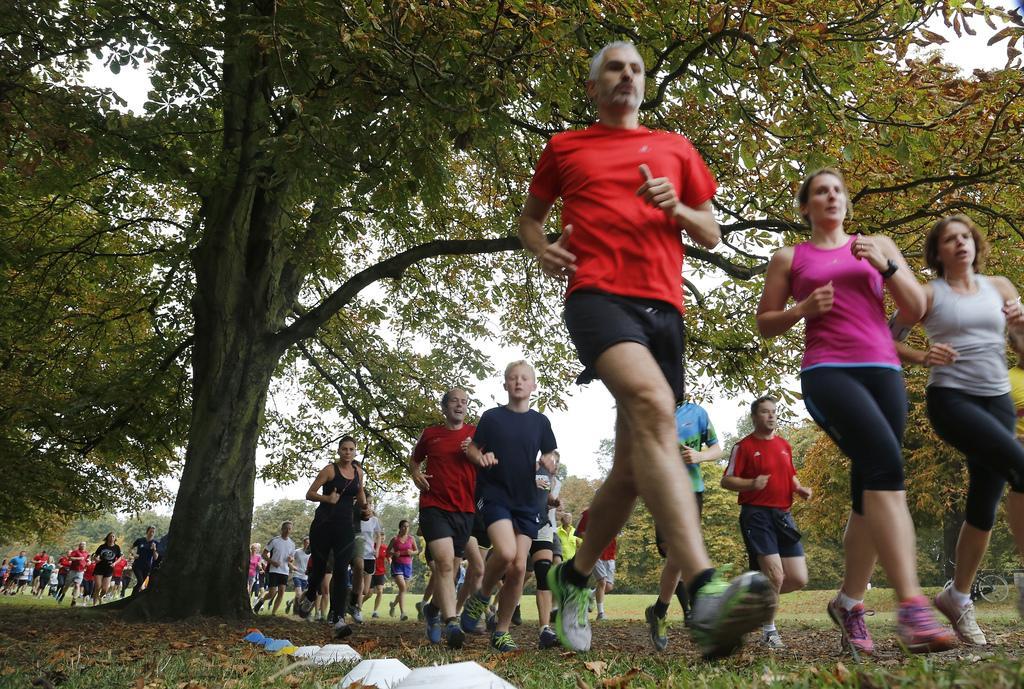How would you summarize this image in a sentence or two? Here a man is running, he wore a red color t-shirt, in the right side 2 girls are running. In the left side it's a tree. 